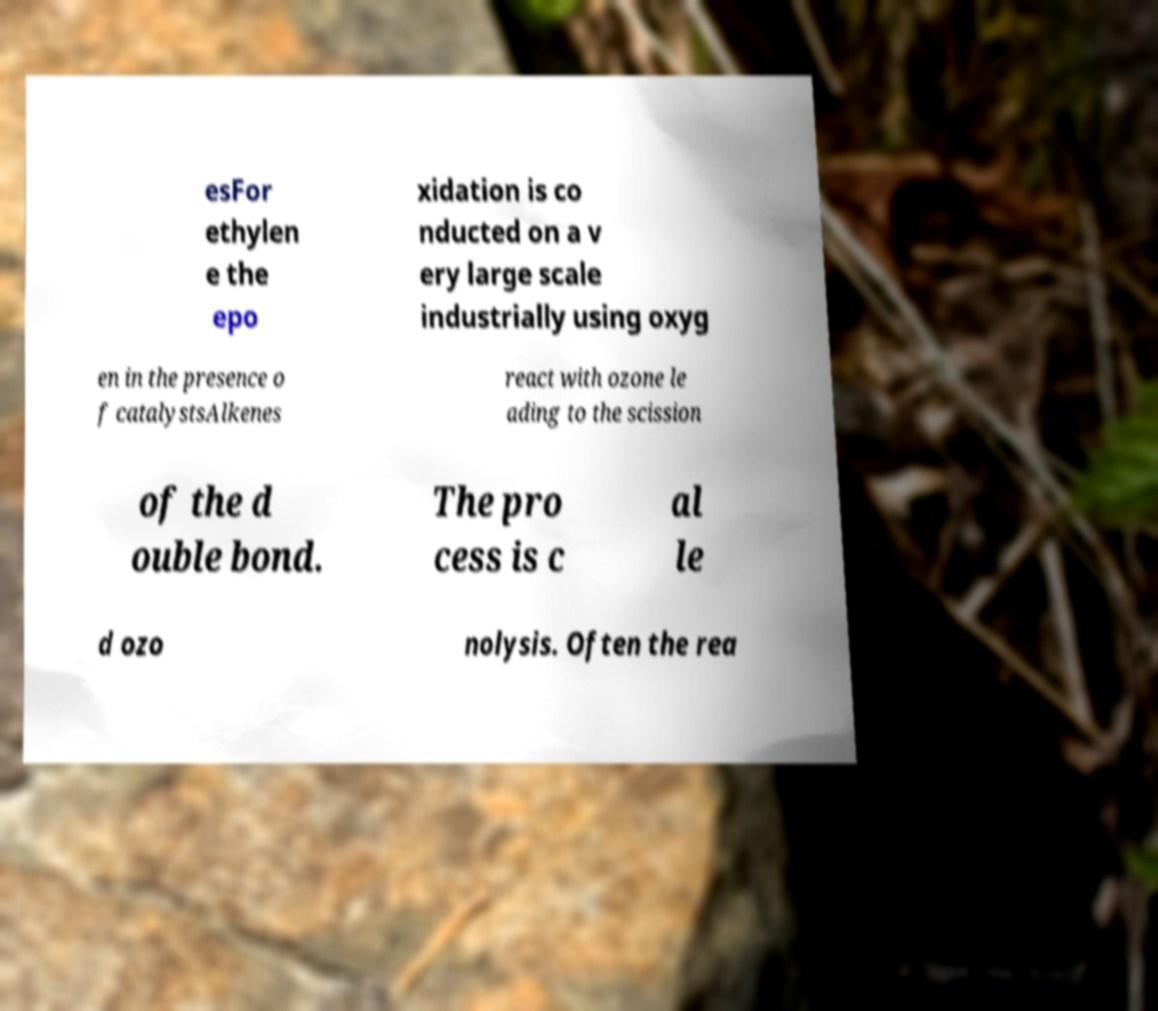Please identify and transcribe the text found in this image. esFor ethylen e the epo xidation is co nducted on a v ery large scale industrially using oxyg en in the presence o f catalystsAlkenes react with ozone le ading to the scission of the d ouble bond. The pro cess is c al le d ozo nolysis. Often the rea 